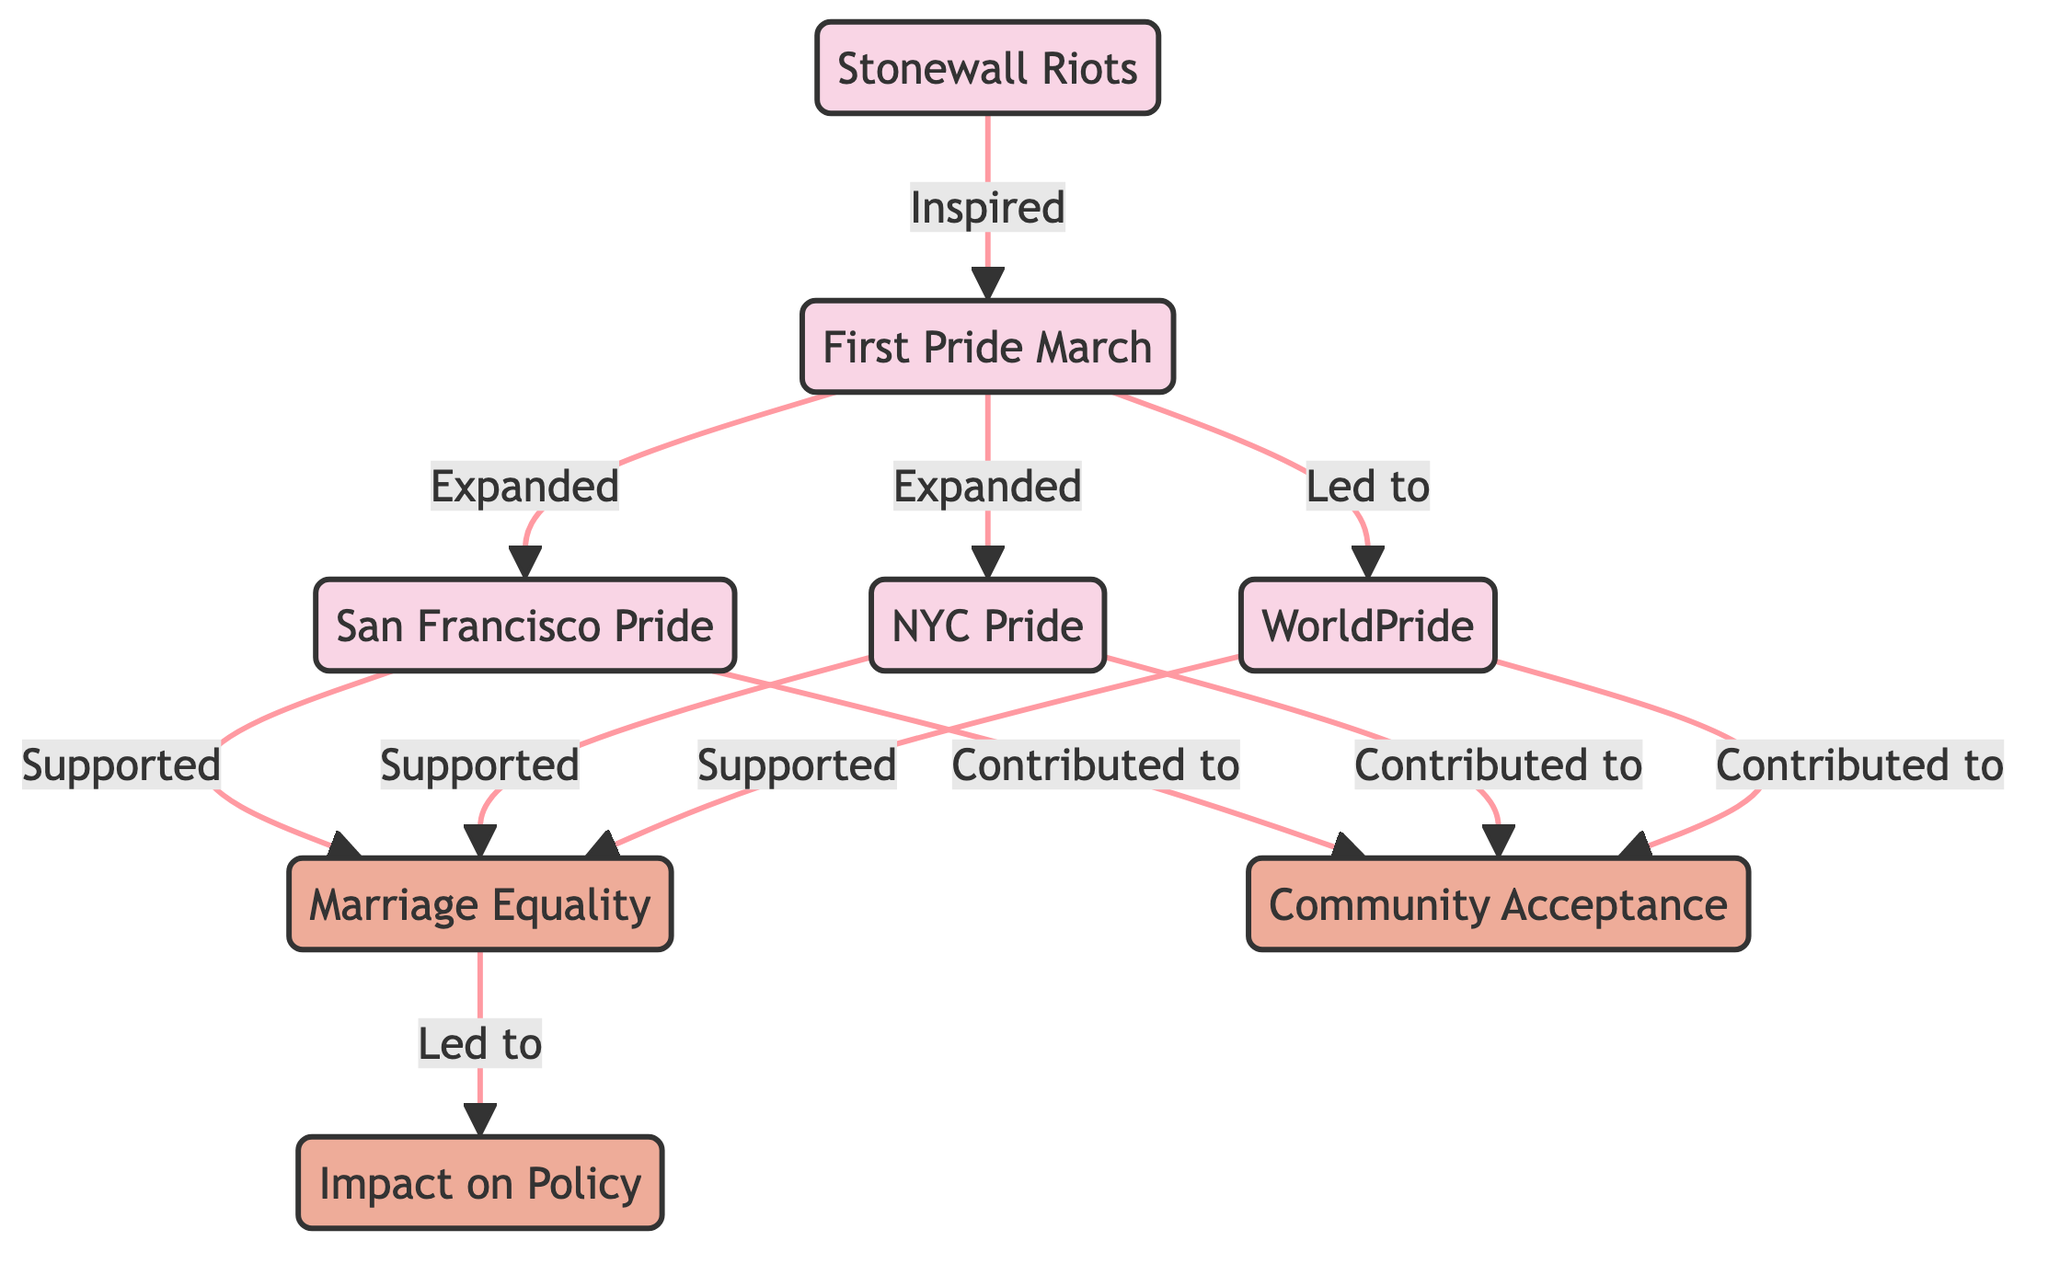What event inspired the First Pride March? The First Pride March directly follows the Stonewall Riots in the diagram, indicating that the Stonewall Riots served as the source of inspiration for this event.
Answer: Stonewall Riots How many edges are outgoing from the First Pride March? By examining the connections in the diagram, the First Pride March has three outgoing edges that connect to San Francisco Pride, NYC Pride, and World Pride.
Answer: 3 What is the relationship between San Francisco Pride and Marriage Equality? The diagram shows that San Francisco Pride has a direct connection to Marriage Equality with the label "Supported," meaning that this event backs the marriage equality movement.
Answer: Supported Which Pride event is noted for contributing to Community Acceptance? The diagram indicates that San Francisco Pride, NYC Pride, and World Pride all contribute to Community Acceptance, showing a clear support network to foster acceptance in society.
Answer: San Francisco Pride, NYC Pride, World Pride What was the first event in this directed graph? The directed graph lays out the events chronologically, beginning with the Stonewall Riots, which are at the top and serve as the starting point for the subsequent events.
Answer: Stonewall Riots Which event led to an impact on policy? The diagram signifies that Marriage Equality is the central node leading to Impact on Policy, as the edges indicate that the push for marriage equality results in changes in laws and policies for the LGBTQ+ community.
Answer: Marriage Equality How many total nodes are present in the diagram? Counting all nodes represented in the diagram, including events and impacts, results in a total of eight distinct nodes.
Answer: 8 What does WorldPride support according to the diagram? The directed graph illustrates that WorldPride directly supports the Marriage Equality movement, marking its role in promoting LGBTQ+ rights on a global scale.
Answer: Marriage Equality 